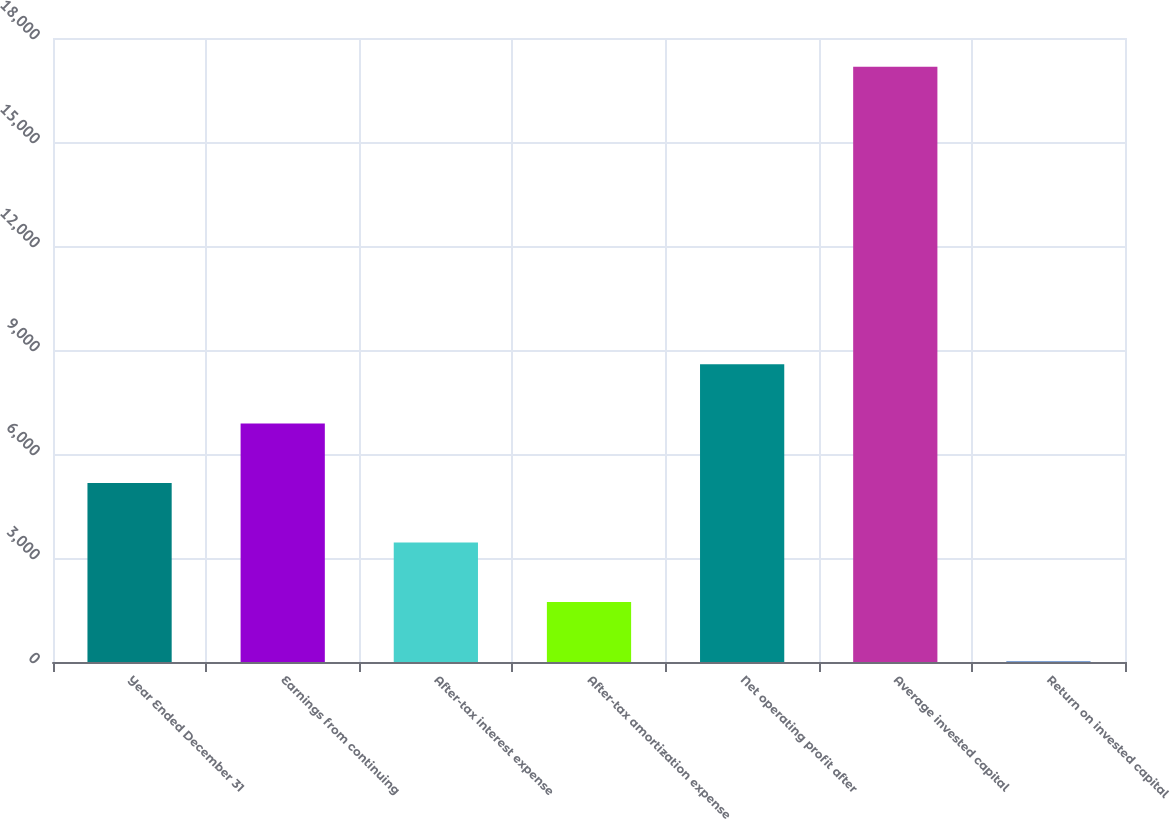Convert chart to OTSL. <chart><loc_0><loc_0><loc_500><loc_500><bar_chart><fcel>Year Ended December 31<fcel>Earnings from continuing<fcel>After-tax interest expense<fcel>After-tax amortization expense<fcel>Net operating profit after<fcel>Average invested capital<fcel>Return on invested capital<nl><fcel>5161.81<fcel>6876.98<fcel>3446.64<fcel>1731.47<fcel>8592.15<fcel>17168<fcel>16.3<nl></chart> 